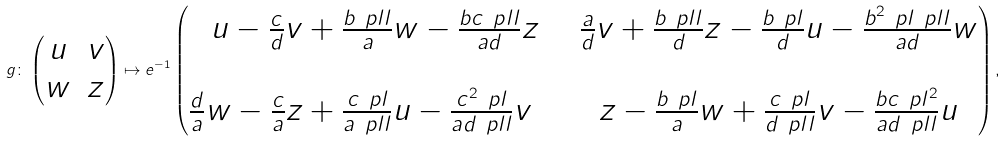<formula> <loc_0><loc_0><loc_500><loc_500>g \colon \left ( \begin{matrix} u & v \\ w & z \end{matrix} \right ) \mapsto e ^ { - 1 } \left ( \begin{matrix} u - \frac { c } { d } v + \frac { b \ p l l } { a } w - \frac { b c \ p l l } { a d } z & \frac { a } { d } v + \frac { b \ p l l } { d } z - \frac { b \ p l } { d } u - \frac { b ^ { 2 } \ p l \ p l l } { a d } w \\ \\ \frac { d } { a } w - \frac { c } { a } z + \frac { c \ p l } { a \ p l l } u - \frac { c ^ { 2 } \ p l } { a d \ p l l } v \quad & z - \frac { b \ p l } { a } w + \frac { c \ p l } { d \ p l l } v - \frac { b c \ p l ^ { 2 } } { a d \ p l l } u \end{matrix} \right ) ,</formula> 